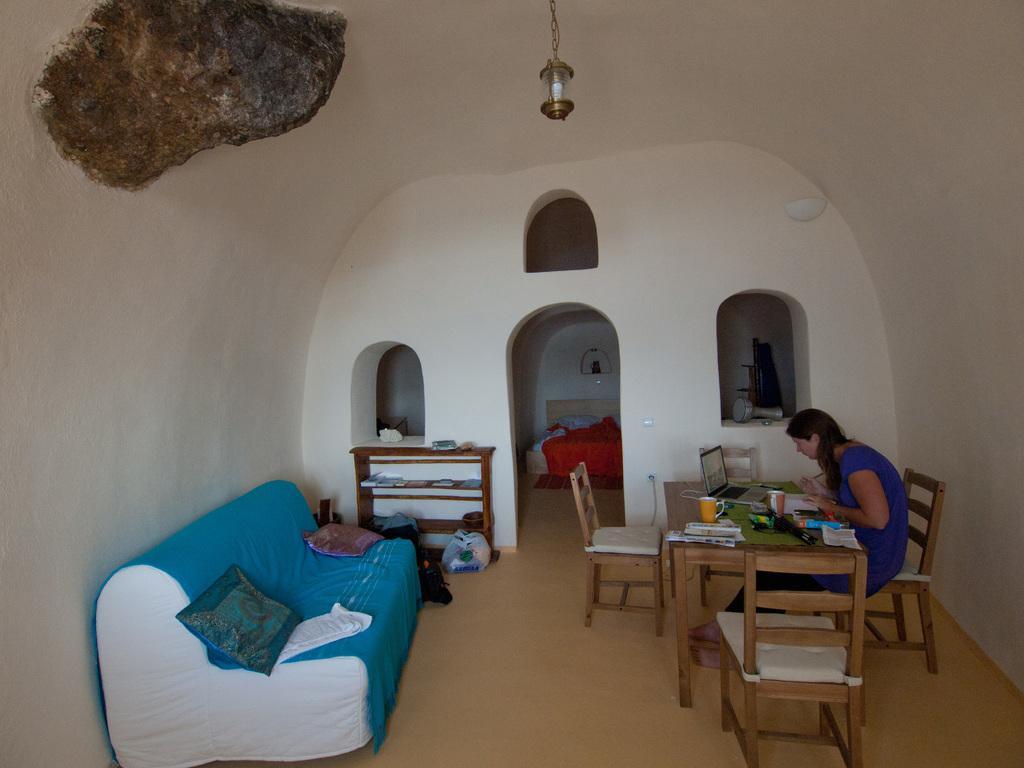How would you summarize this image in a sentence or two? In this image I can see a woman is sitting on a chair. Here I can see few more chairs, a table and a sofa with cushions on it. 